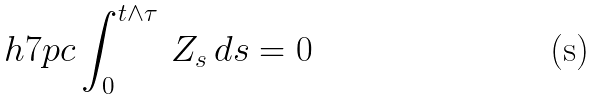Convert formula to latex. <formula><loc_0><loc_0><loc_500><loc_500>\ h { 7 p c } \int _ { 0 } ^ { t \wedge \tau } \, Z _ { s } \, d s = 0</formula> 